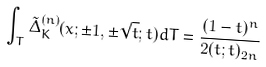<formula> <loc_0><loc_0><loc_500><loc_500>\int _ { T } \tilde { \Delta } _ { K } ^ { ( n ) } ( x ; \pm 1 , \pm \sqrt { t } ; t ) d T & = \frac { ( 1 - t ) ^ { n } } { 2 ( t ; t ) _ { 2 n } }</formula> 